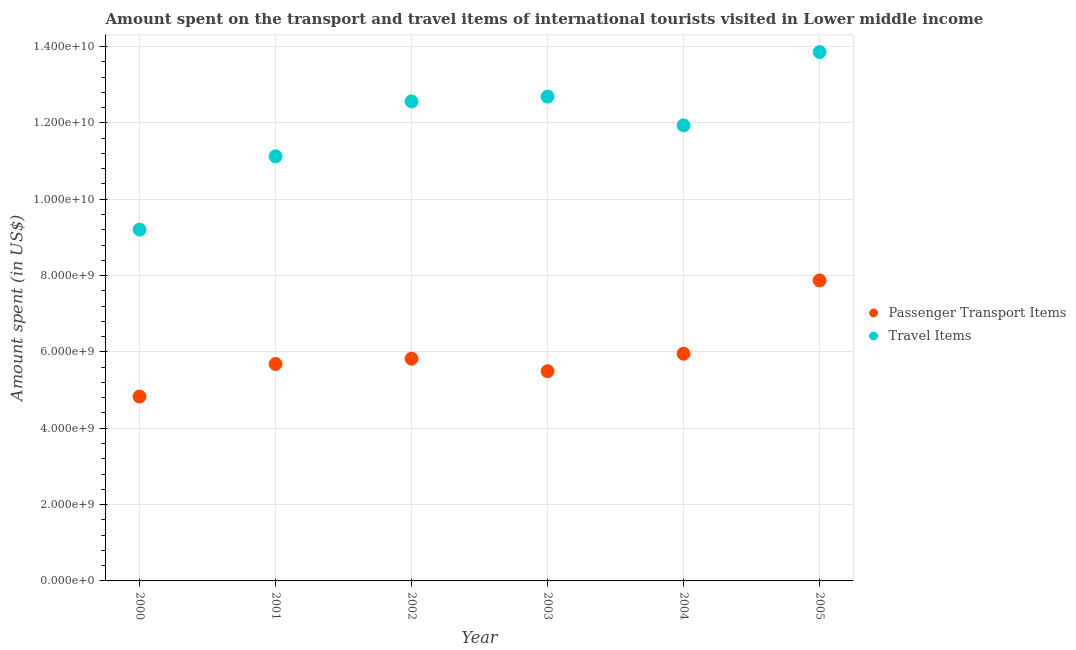What is the amount spent in travel items in 2000?
Make the answer very short. 9.20e+09. Across all years, what is the maximum amount spent in travel items?
Offer a terse response. 1.39e+1. Across all years, what is the minimum amount spent in travel items?
Offer a very short reply. 9.20e+09. What is the total amount spent on passenger transport items in the graph?
Your answer should be compact. 3.57e+1. What is the difference between the amount spent in travel items in 2001 and that in 2005?
Provide a succinct answer. -2.73e+09. What is the difference between the amount spent on passenger transport items in 2003 and the amount spent in travel items in 2001?
Keep it short and to the point. -5.63e+09. What is the average amount spent in travel items per year?
Provide a succinct answer. 1.19e+1. In the year 2000, what is the difference between the amount spent in travel items and amount spent on passenger transport items?
Provide a short and direct response. 4.37e+09. In how many years, is the amount spent in travel items greater than 800000000 US$?
Offer a terse response. 6. What is the ratio of the amount spent in travel items in 2004 to that in 2005?
Your answer should be very brief. 0.86. Is the amount spent in travel items in 2000 less than that in 2001?
Your answer should be compact. Yes. Is the difference between the amount spent on passenger transport items in 2002 and 2004 greater than the difference between the amount spent in travel items in 2002 and 2004?
Provide a short and direct response. No. What is the difference between the highest and the second highest amount spent in travel items?
Keep it short and to the point. 1.17e+09. What is the difference between the highest and the lowest amount spent on passenger transport items?
Offer a terse response. 3.04e+09. Is the sum of the amount spent in travel items in 2002 and 2003 greater than the maximum amount spent on passenger transport items across all years?
Provide a succinct answer. Yes. Is the amount spent on passenger transport items strictly less than the amount spent in travel items over the years?
Your response must be concise. Yes. How many dotlines are there?
Keep it short and to the point. 2. Are the values on the major ticks of Y-axis written in scientific E-notation?
Provide a short and direct response. Yes. Does the graph contain any zero values?
Your answer should be compact. No. How many legend labels are there?
Ensure brevity in your answer.  2. What is the title of the graph?
Provide a short and direct response. Amount spent on the transport and travel items of international tourists visited in Lower middle income. Does "Foreign Liabilities" appear as one of the legend labels in the graph?
Ensure brevity in your answer.  No. What is the label or title of the Y-axis?
Your answer should be compact. Amount spent (in US$). What is the Amount spent (in US$) in Passenger Transport Items in 2000?
Provide a succinct answer. 4.83e+09. What is the Amount spent (in US$) in Travel Items in 2000?
Ensure brevity in your answer.  9.20e+09. What is the Amount spent (in US$) of Passenger Transport Items in 2001?
Offer a very short reply. 5.68e+09. What is the Amount spent (in US$) in Travel Items in 2001?
Provide a short and direct response. 1.11e+1. What is the Amount spent (in US$) in Passenger Transport Items in 2002?
Ensure brevity in your answer.  5.82e+09. What is the Amount spent (in US$) in Travel Items in 2002?
Your answer should be very brief. 1.26e+1. What is the Amount spent (in US$) of Passenger Transport Items in 2003?
Provide a short and direct response. 5.49e+09. What is the Amount spent (in US$) in Travel Items in 2003?
Make the answer very short. 1.27e+1. What is the Amount spent (in US$) in Passenger Transport Items in 2004?
Keep it short and to the point. 5.95e+09. What is the Amount spent (in US$) of Travel Items in 2004?
Offer a very short reply. 1.19e+1. What is the Amount spent (in US$) in Passenger Transport Items in 2005?
Your answer should be very brief. 7.87e+09. What is the Amount spent (in US$) in Travel Items in 2005?
Keep it short and to the point. 1.39e+1. Across all years, what is the maximum Amount spent (in US$) in Passenger Transport Items?
Offer a terse response. 7.87e+09. Across all years, what is the maximum Amount spent (in US$) of Travel Items?
Provide a succinct answer. 1.39e+1. Across all years, what is the minimum Amount spent (in US$) of Passenger Transport Items?
Keep it short and to the point. 4.83e+09. Across all years, what is the minimum Amount spent (in US$) in Travel Items?
Your answer should be compact. 9.20e+09. What is the total Amount spent (in US$) in Passenger Transport Items in the graph?
Give a very brief answer. 3.57e+1. What is the total Amount spent (in US$) of Travel Items in the graph?
Provide a succinct answer. 7.14e+1. What is the difference between the Amount spent (in US$) of Passenger Transport Items in 2000 and that in 2001?
Your response must be concise. -8.53e+08. What is the difference between the Amount spent (in US$) in Travel Items in 2000 and that in 2001?
Provide a short and direct response. -1.92e+09. What is the difference between the Amount spent (in US$) of Passenger Transport Items in 2000 and that in 2002?
Your response must be concise. -9.92e+08. What is the difference between the Amount spent (in US$) of Travel Items in 2000 and that in 2002?
Your answer should be very brief. -3.36e+09. What is the difference between the Amount spent (in US$) in Passenger Transport Items in 2000 and that in 2003?
Your answer should be compact. -6.65e+08. What is the difference between the Amount spent (in US$) in Travel Items in 2000 and that in 2003?
Your answer should be compact. -3.49e+09. What is the difference between the Amount spent (in US$) in Passenger Transport Items in 2000 and that in 2004?
Offer a very short reply. -1.12e+09. What is the difference between the Amount spent (in US$) of Travel Items in 2000 and that in 2004?
Make the answer very short. -2.73e+09. What is the difference between the Amount spent (in US$) of Passenger Transport Items in 2000 and that in 2005?
Make the answer very short. -3.04e+09. What is the difference between the Amount spent (in US$) in Travel Items in 2000 and that in 2005?
Ensure brevity in your answer.  -4.65e+09. What is the difference between the Amount spent (in US$) in Passenger Transport Items in 2001 and that in 2002?
Keep it short and to the point. -1.39e+08. What is the difference between the Amount spent (in US$) in Travel Items in 2001 and that in 2002?
Offer a very short reply. -1.44e+09. What is the difference between the Amount spent (in US$) of Passenger Transport Items in 2001 and that in 2003?
Keep it short and to the point. 1.89e+08. What is the difference between the Amount spent (in US$) in Travel Items in 2001 and that in 2003?
Your response must be concise. -1.57e+09. What is the difference between the Amount spent (in US$) of Passenger Transport Items in 2001 and that in 2004?
Offer a very short reply. -2.69e+08. What is the difference between the Amount spent (in US$) of Travel Items in 2001 and that in 2004?
Provide a succinct answer. -8.12e+08. What is the difference between the Amount spent (in US$) of Passenger Transport Items in 2001 and that in 2005?
Provide a succinct answer. -2.19e+09. What is the difference between the Amount spent (in US$) in Travel Items in 2001 and that in 2005?
Give a very brief answer. -2.73e+09. What is the difference between the Amount spent (in US$) in Passenger Transport Items in 2002 and that in 2003?
Keep it short and to the point. 3.27e+08. What is the difference between the Amount spent (in US$) of Travel Items in 2002 and that in 2003?
Provide a succinct answer. -1.25e+08. What is the difference between the Amount spent (in US$) of Passenger Transport Items in 2002 and that in 2004?
Give a very brief answer. -1.31e+08. What is the difference between the Amount spent (in US$) of Travel Items in 2002 and that in 2004?
Offer a very short reply. 6.28e+08. What is the difference between the Amount spent (in US$) in Passenger Transport Items in 2002 and that in 2005?
Your answer should be compact. -2.05e+09. What is the difference between the Amount spent (in US$) of Travel Items in 2002 and that in 2005?
Your answer should be compact. -1.29e+09. What is the difference between the Amount spent (in US$) of Passenger Transport Items in 2003 and that in 2004?
Keep it short and to the point. -4.58e+08. What is the difference between the Amount spent (in US$) of Travel Items in 2003 and that in 2004?
Provide a succinct answer. 7.53e+08. What is the difference between the Amount spent (in US$) of Passenger Transport Items in 2003 and that in 2005?
Provide a short and direct response. -2.38e+09. What is the difference between the Amount spent (in US$) in Travel Items in 2003 and that in 2005?
Keep it short and to the point. -1.17e+09. What is the difference between the Amount spent (in US$) in Passenger Transport Items in 2004 and that in 2005?
Keep it short and to the point. -1.92e+09. What is the difference between the Amount spent (in US$) in Travel Items in 2004 and that in 2005?
Your answer should be very brief. -1.92e+09. What is the difference between the Amount spent (in US$) of Passenger Transport Items in 2000 and the Amount spent (in US$) of Travel Items in 2001?
Your answer should be very brief. -6.29e+09. What is the difference between the Amount spent (in US$) in Passenger Transport Items in 2000 and the Amount spent (in US$) in Travel Items in 2002?
Provide a short and direct response. -7.73e+09. What is the difference between the Amount spent (in US$) in Passenger Transport Items in 2000 and the Amount spent (in US$) in Travel Items in 2003?
Your answer should be compact. -7.86e+09. What is the difference between the Amount spent (in US$) in Passenger Transport Items in 2000 and the Amount spent (in US$) in Travel Items in 2004?
Your response must be concise. -7.11e+09. What is the difference between the Amount spent (in US$) in Passenger Transport Items in 2000 and the Amount spent (in US$) in Travel Items in 2005?
Keep it short and to the point. -9.03e+09. What is the difference between the Amount spent (in US$) in Passenger Transport Items in 2001 and the Amount spent (in US$) in Travel Items in 2002?
Offer a terse response. -6.88e+09. What is the difference between the Amount spent (in US$) in Passenger Transport Items in 2001 and the Amount spent (in US$) in Travel Items in 2003?
Your response must be concise. -7.01e+09. What is the difference between the Amount spent (in US$) of Passenger Transport Items in 2001 and the Amount spent (in US$) of Travel Items in 2004?
Offer a very short reply. -6.25e+09. What is the difference between the Amount spent (in US$) of Passenger Transport Items in 2001 and the Amount spent (in US$) of Travel Items in 2005?
Offer a very short reply. -8.17e+09. What is the difference between the Amount spent (in US$) of Passenger Transport Items in 2002 and the Amount spent (in US$) of Travel Items in 2003?
Your answer should be compact. -6.87e+09. What is the difference between the Amount spent (in US$) of Passenger Transport Items in 2002 and the Amount spent (in US$) of Travel Items in 2004?
Offer a very short reply. -6.11e+09. What is the difference between the Amount spent (in US$) of Passenger Transport Items in 2002 and the Amount spent (in US$) of Travel Items in 2005?
Provide a succinct answer. -8.03e+09. What is the difference between the Amount spent (in US$) in Passenger Transport Items in 2003 and the Amount spent (in US$) in Travel Items in 2004?
Ensure brevity in your answer.  -6.44e+09. What is the difference between the Amount spent (in US$) in Passenger Transport Items in 2003 and the Amount spent (in US$) in Travel Items in 2005?
Your answer should be very brief. -8.36e+09. What is the difference between the Amount spent (in US$) in Passenger Transport Items in 2004 and the Amount spent (in US$) in Travel Items in 2005?
Make the answer very short. -7.90e+09. What is the average Amount spent (in US$) of Passenger Transport Items per year?
Make the answer very short. 5.94e+09. What is the average Amount spent (in US$) of Travel Items per year?
Your answer should be very brief. 1.19e+1. In the year 2000, what is the difference between the Amount spent (in US$) of Passenger Transport Items and Amount spent (in US$) of Travel Items?
Your answer should be compact. -4.37e+09. In the year 2001, what is the difference between the Amount spent (in US$) in Passenger Transport Items and Amount spent (in US$) in Travel Items?
Offer a very short reply. -5.44e+09. In the year 2002, what is the difference between the Amount spent (in US$) of Passenger Transport Items and Amount spent (in US$) of Travel Items?
Offer a very short reply. -6.74e+09. In the year 2003, what is the difference between the Amount spent (in US$) in Passenger Transport Items and Amount spent (in US$) in Travel Items?
Give a very brief answer. -7.19e+09. In the year 2004, what is the difference between the Amount spent (in US$) in Passenger Transport Items and Amount spent (in US$) in Travel Items?
Ensure brevity in your answer.  -5.98e+09. In the year 2005, what is the difference between the Amount spent (in US$) in Passenger Transport Items and Amount spent (in US$) in Travel Items?
Your answer should be compact. -5.98e+09. What is the ratio of the Amount spent (in US$) in Passenger Transport Items in 2000 to that in 2001?
Ensure brevity in your answer.  0.85. What is the ratio of the Amount spent (in US$) in Travel Items in 2000 to that in 2001?
Give a very brief answer. 0.83. What is the ratio of the Amount spent (in US$) in Passenger Transport Items in 2000 to that in 2002?
Your answer should be compact. 0.83. What is the ratio of the Amount spent (in US$) in Travel Items in 2000 to that in 2002?
Keep it short and to the point. 0.73. What is the ratio of the Amount spent (in US$) in Passenger Transport Items in 2000 to that in 2003?
Your response must be concise. 0.88. What is the ratio of the Amount spent (in US$) of Travel Items in 2000 to that in 2003?
Your answer should be compact. 0.73. What is the ratio of the Amount spent (in US$) in Passenger Transport Items in 2000 to that in 2004?
Make the answer very short. 0.81. What is the ratio of the Amount spent (in US$) of Travel Items in 2000 to that in 2004?
Ensure brevity in your answer.  0.77. What is the ratio of the Amount spent (in US$) in Passenger Transport Items in 2000 to that in 2005?
Make the answer very short. 0.61. What is the ratio of the Amount spent (in US$) in Travel Items in 2000 to that in 2005?
Make the answer very short. 0.66. What is the ratio of the Amount spent (in US$) of Passenger Transport Items in 2001 to that in 2002?
Make the answer very short. 0.98. What is the ratio of the Amount spent (in US$) of Travel Items in 2001 to that in 2002?
Provide a short and direct response. 0.89. What is the ratio of the Amount spent (in US$) of Passenger Transport Items in 2001 to that in 2003?
Give a very brief answer. 1.03. What is the ratio of the Amount spent (in US$) of Travel Items in 2001 to that in 2003?
Provide a short and direct response. 0.88. What is the ratio of the Amount spent (in US$) of Passenger Transport Items in 2001 to that in 2004?
Offer a very short reply. 0.95. What is the ratio of the Amount spent (in US$) in Travel Items in 2001 to that in 2004?
Provide a short and direct response. 0.93. What is the ratio of the Amount spent (in US$) in Passenger Transport Items in 2001 to that in 2005?
Provide a succinct answer. 0.72. What is the ratio of the Amount spent (in US$) of Travel Items in 2001 to that in 2005?
Provide a succinct answer. 0.8. What is the ratio of the Amount spent (in US$) of Passenger Transport Items in 2002 to that in 2003?
Provide a short and direct response. 1.06. What is the ratio of the Amount spent (in US$) in Travel Items in 2002 to that in 2004?
Give a very brief answer. 1.05. What is the ratio of the Amount spent (in US$) in Passenger Transport Items in 2002 to that in 2005?
Offer a terse response. 0.74. What is the ratio of the Amount spent (in US$) in Travel Items in 2002 to that in 2005?
Provide a short and direct response. 0.91. What is the ratio of the Amount spent (in US$) of Passenger Transport Items in 2003 to that in 2004?
Make the answer very short. 0.92. What is the ratio of the Amount spent (in US$) of Travel Items in 2003 to that in 2004?
Your answer should be very brief. 1.06. What is the ratio of the Amount spent (in US$) in Passenger Transport Items in 2003 to that in 2005?
Make the answer very short. 0.7. What is the ratio of the Amount spent (in US$) in Travel Items in 2003 to that in 2005?
Offer a terse response. 0.92. What is the ratio of the Amount spent (in US$) of Passenger Transport Items in 2004 to that in 2005?
Your answer should be compact. 0.76. What is the ratio of the Amount spent (in US$) in Travel Items in 2004 to that in 2005?
Your response must be concise. 0.86. What is the difference between the highest and the second highest Amount spent (in US$) in Passenger Transport Items?
Your response must be concise. 1.92e+09. What is the difference between the highest and the second highest Amount spent (in US$) in Travel Items?
Keep it short and to the point. 1.17e+09. What is the difference between the highest and the lowest Amount spent (in US$) in Passenger Transport Items?
Make the answer very short. 3.04e+09. What is the difference between the highest and the lowest Amount spent (in US$) of Travel Items?
Offer a very short reply. 4.65e+09. 